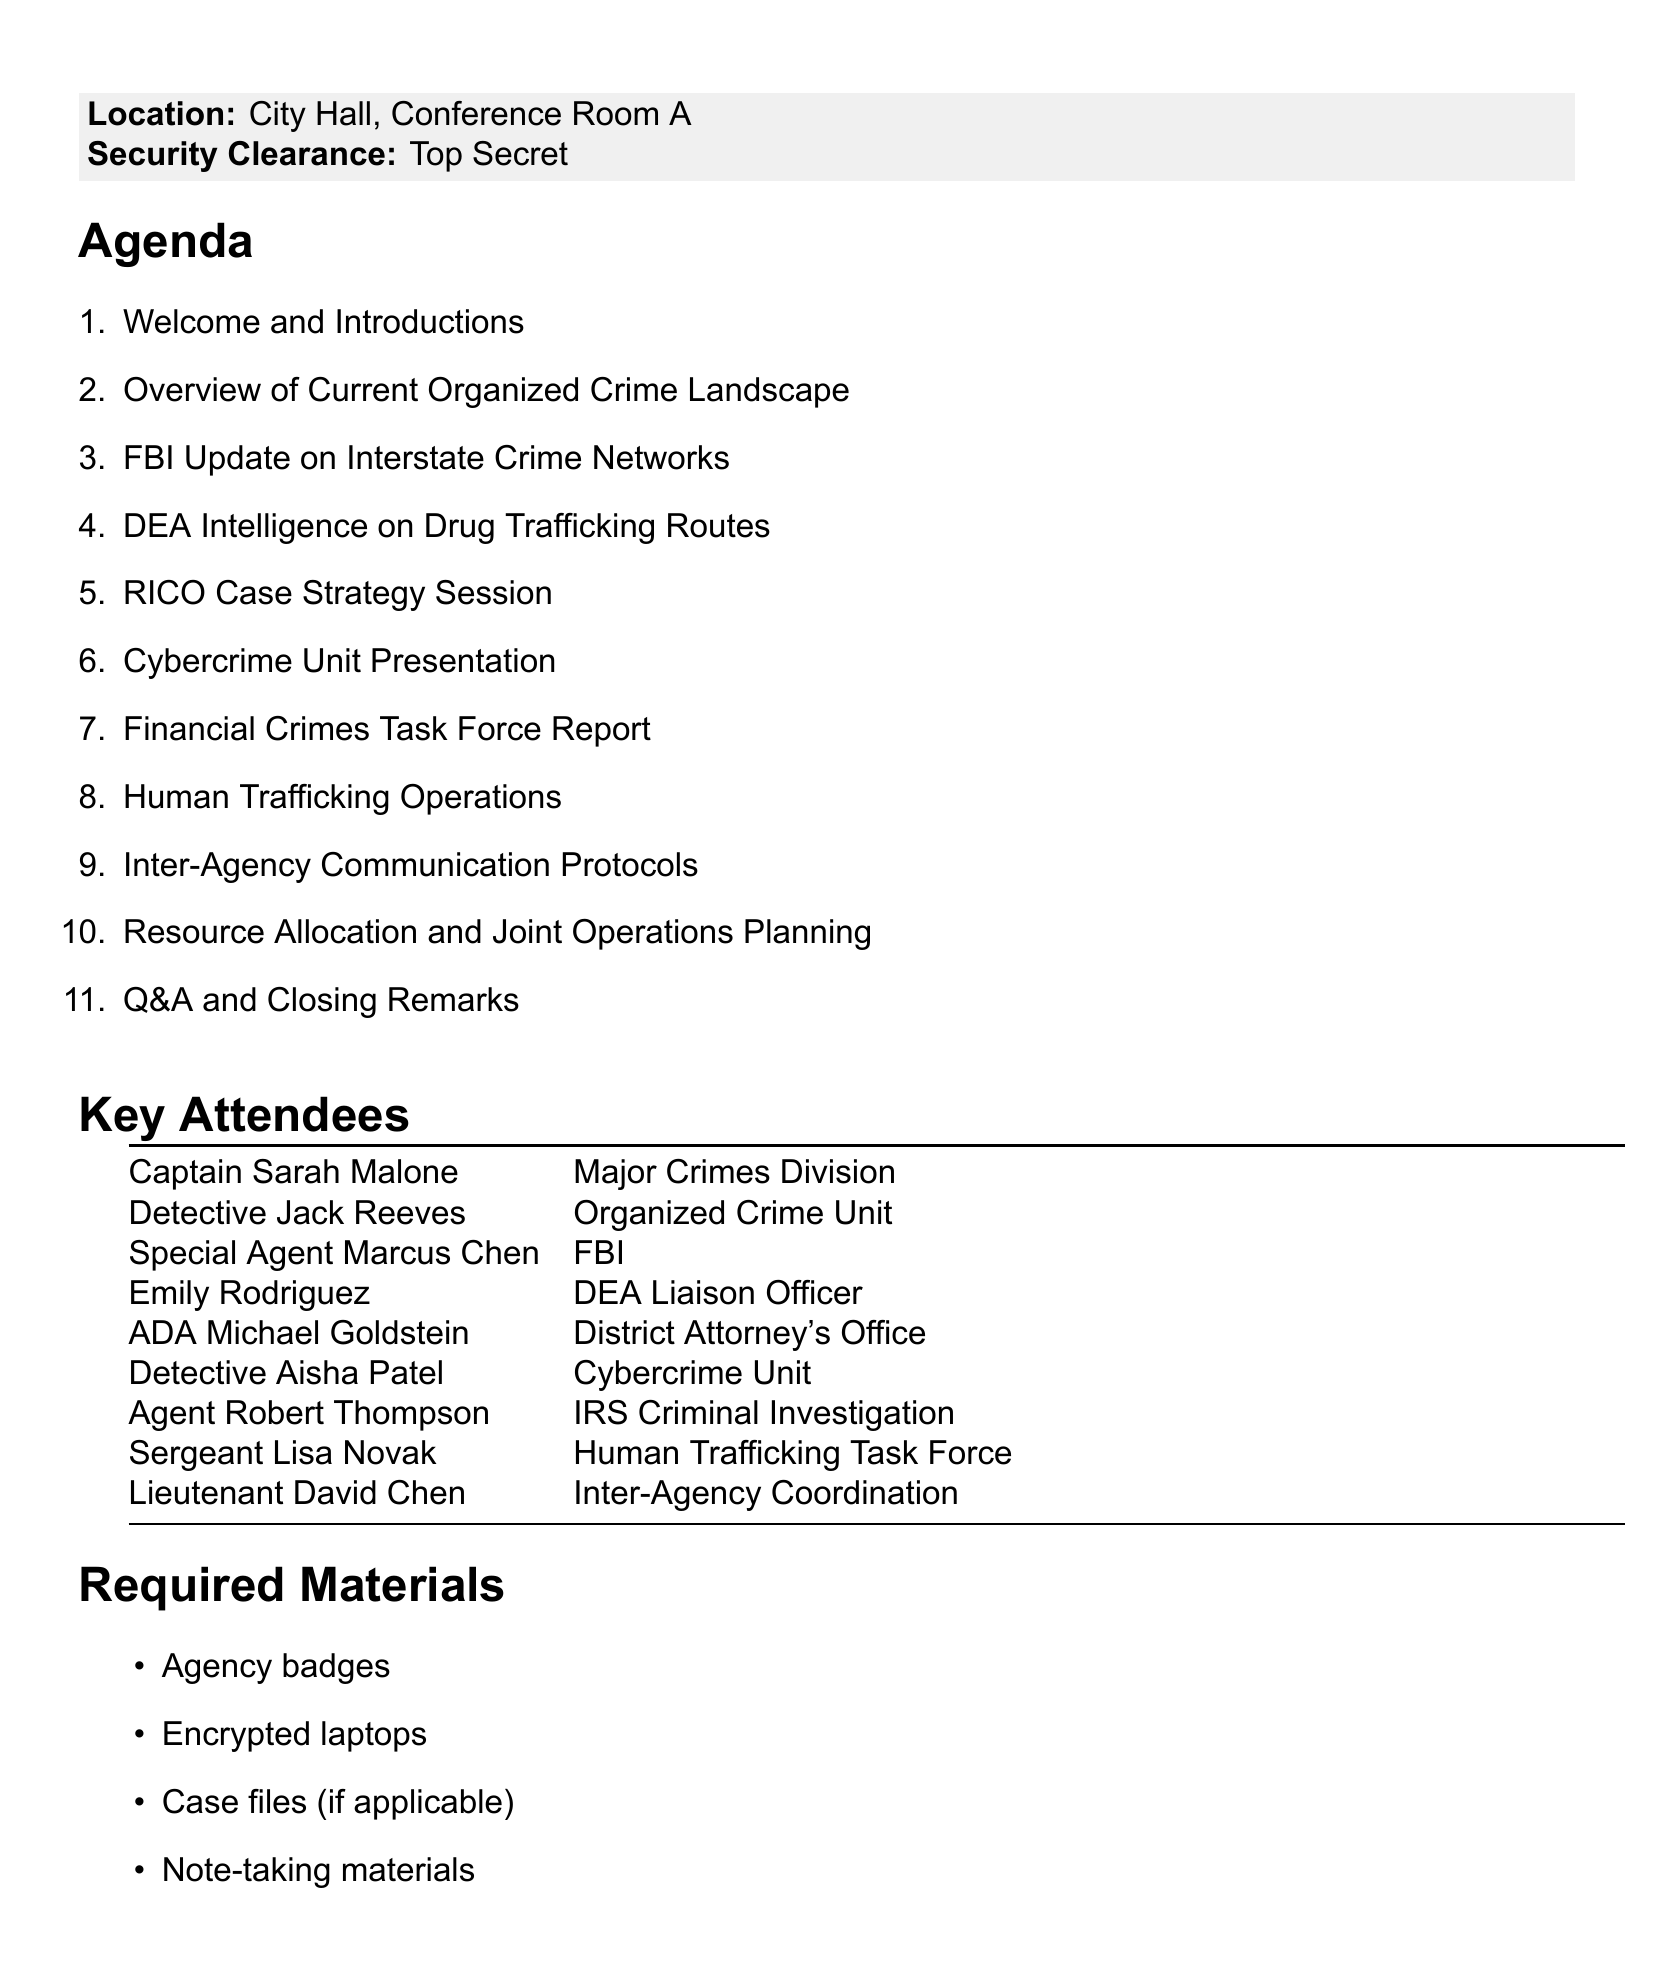What is the date of the briefing? The date is specified at the beginning of the document.
Answer: May 15, 2023 Who is presenting the overview of the current organized crime landscape? This information can be found in the agenda items section.
Answer: Detective Jack Reeves What is the location of the meeting? The location is stated clearly in the document section regarding the meeting details.
Answer: City Hall, Conference Room A How many agenda items are listed in the document? The document enumerates the agenda items, allowing for a simple count.
Answer: 11 What specific protocol is discussed for inter-agency communication? This is mentioned in the agenda list related to inter-agency communication.
Answer: Inter-Agency Communication Protocols Which agent is responsible for the FBI update? The document identifies the agent delivering this update in the attendees section.
Answer: Special Agent Marcus Chen What type of security clearance is required for attendance? This requirement is indicated within the meeting details section.
Answer: Top Secret Who is leading the RICO case strategy session? This is specified in the document under the respective agenda item.
Answer: Assistant District Attorney Michael Goldstein 